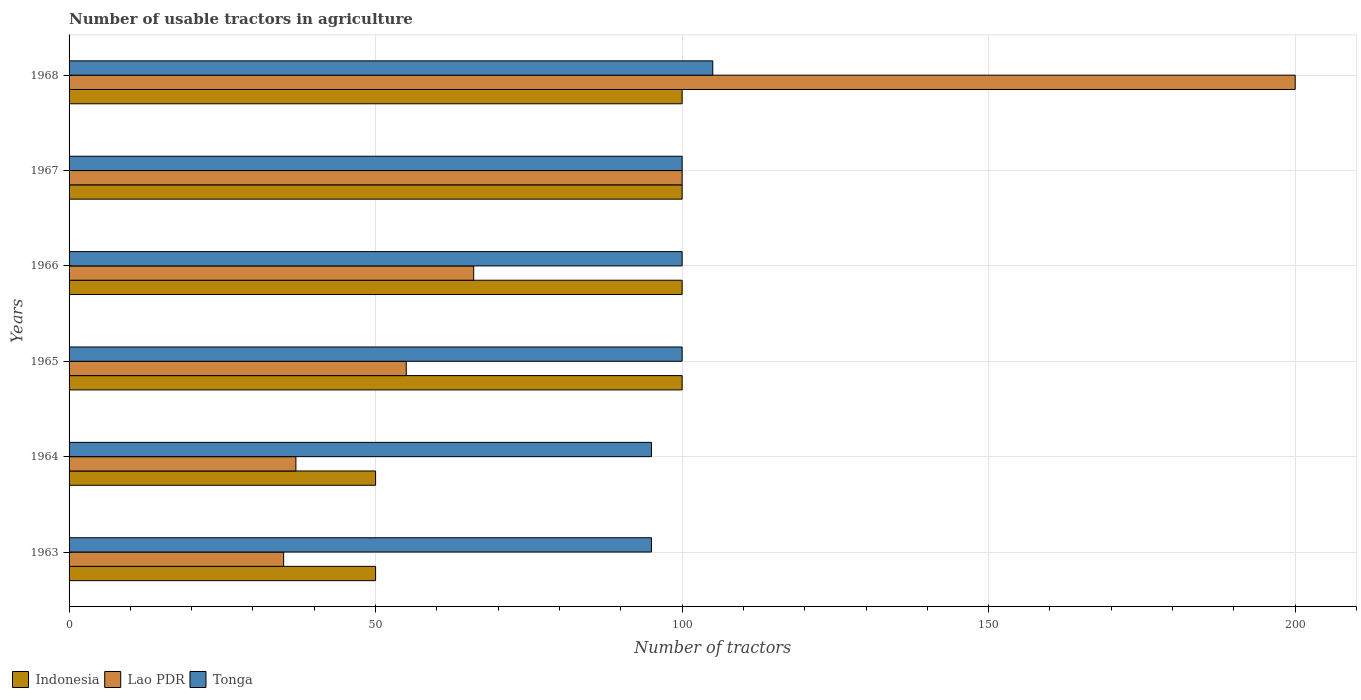Are the number of bars on each tick of the Y-axis equal?
Your answer should be very brief. Yes. How many bars are there on the 5th tick from the top?
Offer a very short reply. 3. What is the label of the 2nd group of bars from the top?
Your response must be concise. 1967. In how many cases, is the number of bars for a given year not equal to the number of legend labels?
Ensure brevity in your answer.  0. What is the number of usable tractors in agriculture in Indonesia in 1968?
Offer a terse response. 100. Across all years, what is the maximum number of usable tractors in agriculture in Tonga?
Offer a terse response. 105. In which year was the number of usable tractors in agriculture in Indonesia maximum?
Keep it short and to the point. 1965. What is the total number of usable tractors in agriculture in Lao PDR in the graph?
Offer a terse response. 493. What is the difference between the number of usable tractors in agriculture in Lao PDR in 1966 and that in 1967?
Offer a terse response. -34. What is the difference between the number of usable tractors in agriculture in Lao PDR in 1966 and the number of usable tractors in agriculture in Indonesia in 1965?
Give a very brief answer. -34. What is the average number of usable tractors in agriculture in Tonga per year?
Your response must be concise. 99.17. Is the number of usable tractors in agriculture in Tonga in 1963 less than that in 1965?
Make the answer very short. Yes. Is the difference between the number of usable tractors in agriculture in Tonga in 1965 and 1968 greater than the difference between the number of usable tractors in agriculture in Lao PDR in 1965 and 1968?
Give a very brief answer. Yes. What is the difference between the highest and the second highest number of usable tractors in agriculture in Indonesia?
Provide a short and direct response. 0. What is the difference between the highest and the lowest number of usable tractors in agriculture in Lao PDR?
Keep it short and to the point. 165. What does the 2nd bar from the top in 1963 represents?
Your response must be concise. Lao PDR. Is it the case that in every year, the sum of the number of usable tractors in agriculture in Tonga and number of usable tractors in agriculture in Indonesia is greater than the number of usable tractors in agriculture in Lao PDR?
Your response must be concise. Yes. How many bars are there?
Ensure brevity in your answer.  18. Are all the bars in the graph horizontal?
Provide a succinct answer. Yes. Does the graph contain any zero values?
Offer a very short reply. No. Does the graph contain grids?
Make the answer very short. Yes. What is the title of the graph?
Your response must be concise. Number of usable tractors in agriculture. What is the label or title of the X-axis?
Provide a short and direct response. Number of tractors. What is the label or title of the Y-axis?
Provide a short and direct response. Years. What is the Number of tractors in Tonga in 1963?
Your answer should be compact. 95. What is the Number of tractors of Lao PDR in 1966?
Offer a very short reply. 66. What is the Number of tractors in Indonesia in 1967?
Offer a very short reply. 100. What is the Number of tractors in Lao PDR in 1967?
Give a very brief answer. 100. What is the Number of tractors of Indonesia in 1968?
Your response must be concise. 100. What is the Number of tractors of Lao PDR in 1968?
Keep it short and to the point. 200. What is the Number of tractors in Tonga in 1968?
Provide a short and direct response. 105. Across all years, what is the maximum Number of tractors of Lao PDR?
Offer a terse response. 200. Across all years, what is the maximum Number of tractors of Tonga?
Keep it short and to the point. 105. Across all years, what is the minimum Number of tractors of Indonesia?
Offer a terse response. 50. Across all years, what is the minimum Number of tractors in Lao PDR?
Give a very brief answer. 35. What is the total Number of tractors in Indonesia in the graph?
Give a very brief answer. 500. What is the total Number of tractors in Lao PDR in the graph?
Ensure brevity in your answer.  493. What is the total Number of tractors of Tonga in the graph?
Your response must be concise. 595. What is the difference between the Number of tractors of Indonesia in 1963 and that in 1964?
Your answer should be very brief. 0. What is the difference between the Number of tractors of Lao PDR in 1963 and that in 1966?
Ensure brevity in your answer.  -31. What is the difference between the Number of tractors of Tonga in 1963 and that in 1966?
Ensure brevity in your answer.  -5. What is the difference between the Number of tractors of Lao PDR in 1963 and that in 1967?
Provide a short and direct response. -65. What is the difference between the Number of tractors in Tonga in 1963 and that in 1967?
Your response must be concise. -5. What is the difference between the Number of tractors of Indonesia in 1963 and that in 1968?
Keep it short and to the point. -50. What is the difference between the Number of tractors of Lao PDR in 1963 and that in 1968?
Ensure brevity in your answer.  -165. What is the difference between the Number of tractors of Tonga in 1963 and that in 1968?
Offer a very short reply. -10. What is the difference between the Number of tractors of Tonga in 1964 and that in 1965?
Your response must be concise. -5. What is the difference between the Number of tractors of Tonga in 1964 and that in 1966?
Your answer should be very brief. -5. What is the difference between the Number of tractors of Indonesia in 1964 and that in 1967?
Your answer should be compact. -50. What is the difference between the Number of tractors of Lao PDR in 1964 and that in 1967?
Offer a terse response. -63. What is the difference between the Number of tractors in Indonesia in 1964 and that in 1968?
Provide a short and direct response. -50. What is the difference between the Number of tractors of Lao PDR in 1964 and that in 1968?
Offer a terse response. -163. What is the difference between the Number of tractors in Tonga in 1964 and that in 1968?
Your answer should be compact. -10. What is the difference between the Number of tractors in Indonesia in 1965 and that in 1966?
Your answer should be compact. 0. What is the difference between the Number of tractors in Lao PDR in 1965 and that in 1967?
Provide a short and direct response. -45. What is the difference between the Number of tractors in Tonga in 1965 and that in 1967?
Provide a succinct answer. 0. What is the difference between the Number of tractors of Indonesia in 1965 and that in 1968?
Give a very brief answer. 0. What is the difference between the Number of tractors of Lao PDR in 1965 and that in 1968?
Your response must be concise. -145. What is the difference between the Number of tractors in Indonesia in 1966 and that in 1967?
Provide a succinct answer. 0. What is the difference between the Number of tractors of Lao PDR in 1966 and that in 1967?
Offer a terse response. -34. What is the difference between the Number of tractors in Lao PDR in 1966 and that in 1968?
Your answer should be very brief. -134. What is the difference between the Number of tractors of Tonga in 1966 and that in 1968?
Ensure brevity in your answer.  -5. What is the difference between the Number of tractors of Indonesia in 1967 and that in 1968?
Ensure brevity in your answer.  0. What is the difference between the Number of tractors in Lao PDR in 1967 and that in 1968?
Your response must be concise. -100. What is the difference between the Number of tractors in Tonga in 1967 and that in 1968?
Offer a very short reply. -5. What is the difference between the Number of tractors in Indonesia in 1963 and the Number of tractors in Tonga in 1964?
Your answer should be compact. -45. What is the difference between the Number of tractors in Lao PDR in 1963 and the Number of tractors in Tonga in 1964?
Give a very brief answer. -60. What is the difference between the Number of tractors in Lao PDR in 1963 and the Number of tractors in Tonga in 1965?
Your answer should be compact. -65. What is the difference between the Number of tractors of Lao PDR in 1963 and the Number of tractors of Tonga in 1966?
Offer a terse response. -65. What is the difference between the Number of tractors of Indonesia in 1963 and the Number of tractors of Lao PDR in 1967?
Provide a succinct answer. -50. What is the difference between the Number of tractors of Indonesia in 1963 and the Number of tractors of Tonga in 1967?
Ensure brevity in your answer.  -50. What is the difference between the Number of tractors in Lao PDR in 1963 and the Number of tractors in Tonga in 1967?
Your answer should be very brief. -65. What is the difference between the Number of tractors of Indonesia in 1963 and the Number of tractors of Lao PDR in 1968?
Your answer should be very brief. -150. What is the difference between the Number of tractors in Indonesia in 1963 and the Number of tractors in Tonga in 1968?
Offer a terse response. -55. What is the difference between the Number of tractors in Lao PDR in 1963 and the Number of tractors in Tonga in 1968?
Keep it short and to the point. -70. What is the difference between the Number of tractors of Lao PDR in 1964 and the Number of tractors of Tonga in 1965?
Offer a very short reply. -63. What is the difference between the Number of tractors of Indonesia in 1964 and the Number of tractors of Lao PDR in 1966?
Offer a terse response. -16. What is the difference between the Number of tractors of Indonesia in 1964 and the Number of tractors of Tonga in 1966?
Keep it short and to the point. -50. What is the difference between the Number of tractors of Lao PDR in 1964 and the Number of tractors of Tonga in 1966?
Provide a short and direct response. -63. What is the difference between the Number of tractors of Lao PDR in 1964 and the Number of tractors of Tonga in 1967?
Your answer should be compact. -63. What is the difference between the Number of tractors in Indonesia in 1964 and the Number of tractors in Lao PDR in 1968?
Your response must be concise. -150. What is the difference between the Number of tractors of Indonesia in 1964 and the Number of tractors of Tonga in 1968?
Your answer should be very brief. -55. What is the difference between the Number of tractors of Lao PDR in 1964 and the Number of tractors of Tonga in 1968?
Your answer should be compact. -68. What is the difference between the Number of tractors of Indonesia in 1965 and the Number of tractors of Lao PDR in 1966?
Provide a short and direct response. 34. What is the difference between the Number of tractors in Lao PDR in 1965 and the Number of tractors in Tonga in 1966?
Make the answer very short. -45. What is the difference between the Number of tractors in Indonesia in 1965 and the Number of tractors in Lao PDR in 1967?
Your response must be concise. 0. What is the difference between the Number of tractors in Indonesia in 1965 and the Number of tractors in Tonga in 1967?
Your response must be concise. 0. What is the difference between the Number of tractors in Lao PDR in 1965 and the Number of tractors in Tonga in 1967?
Keep it short and to the point. -45. What is the difference between the Number of tractors of Indonesia in 1965 and the Number of tractors of Lao PDR in 1968?
Offer a very short reply. -100. What is the difference between the Number of tractors of Indonesia in 1965 and the Number of tractors of Tonga in 1968?
Give a very brief answer. -5. What is the difference between the Number of tractors in Indonesia in 1966 and the Number of tractors in Lao PDR in 1967?
Offer a terse response. 0. What is the difference between the Number of tractors in Lao PDR in 1966 and the Number of tractors in Tonga in 1967?
Your answer should be very brief. -34. What is the difference between the Number of tractors in Indonesia in 1966 and the Number of tractors in Lao PDR in 1968?
Keep it short and to the point. -100. What is the difference between the Number of tractors in Lao PDR in 1966 and the Number of tractors in Tonga in 1968?
Give a very brief answer. -39. What is the difference between the Number of tractors in Indonesia in 1967 and the Number of tractors in Lao PDR in 1968?
Provide a short and direct response. -100. What is the difference between the Number of tractors of Lao PDR in 1967 and the Number of tractors of Tonga in 1968?
Give a very brief answer. -5. What is the average Number of tractors in Indonesia per year?
Your answer should be very brief. 83.33. What is the average Number of tractors in Lao PDR per year?
Your answer should be very brief. 82.17. What is the average Number of tractors of Tonga per year?
Provide a succinct answer. 99.17. In the year 1963, what is the difference between the Number of tractors in Indonesia and Number of tractors in Tonga?
Provide a short and direct response. -45. In the year 1963, what is the difference between the Number of tractors of Lao PDR and Number of tractors of Tonga?
Offer a very short reply. -60. In the year 1964, what is the difference between the Number of tractors in Indonesia and Number of tractors in Tonga?
Your answer should be compact. -45. In the year 1964, what is the difference between the Number of tractors in Lao PDR and Number of tractors in Tonga?
Your response must be concise. -58. In the year 1965, what is the difference between the Number of tractors in Indonesia and Number of tractors in Lao PDR?
Your response must be concise. 45. In the year 1965, what is the difference between the Number of tractors of Indonesia and Number of tractors of Tonga?
Your answer should be compact. 0. In the year 1965, what is the difference between the Number of tractors of Lao PDR and Number of tractors of Tonga?
Keep it short and to the point. -45. In the year 1966, what is the difference between the Number of tractors in Indonesia and Number of tractors in Tonga?
Keep it short and to the point. 0. In the year 1966, what is the difference between the Number of tractors of Lao PDR and Number of tractors of Tonga?
Your response must be concise. -34. In the year 1967, what is the difference between the Number of tractors of Lao PDR and Number of tractors of Tonga?
Provide a succinct answer. 0. In the year 1968, what is the difference between the Number of tractors in Indonesia and Number of tractors in Lao PDR?
Ensure brevity in your answer.  -100. In the year 1968, what is the difference between the Number of tractors of Indonesia and Number of tractors of Tonga?
Your answer should be very brief. -5. What is the ratio of the Number of tractors of Indonesia in 1963 to that in 1964?
Your answer should be very brief. 1. What is the ratio of the Number of tractors in Lao PDR in 1963 to that in 1964?
Keep it short and to the point. 0.95. What is the ratio of the Number of tractors of Lao PDR in 1963 to that in 1965?
Offer a terse response. 0.64. What is the ratio of the Number of tractors of Tonga in 1963 to that in 1965?
Offer a very short reply. 0.95. What is the ratio of the Number of tractors of Lao PDR in 1963 to that in 1966?
Offer a very short reply. 0.53. What is the ratio of the Number of tractors of Indonesia in 1963 to that in 1967?
Your answer should be compact. 0.5. What is the ratio of the Number of tractors of Lao PDR in 1963 to that in 1967?
Offer a terse response. 0.35. What is the ratio of the Number of tractors in Tonga in 1963 to that in 1967?
Ensure brevity in your answer.  0.95. What is the ratio of the Number of tractors of Indonesia in 1963 to that in 1968?
Your answer should be very brief. 0.5. What is the ratio of the Number of tractors in Lao PDR in 1963 to that in 1968?
Your response must be concise. 0.17. What is the ratio of the Number of tractors in Tonga in 1963 to that in 1968?
Your answer should be very brief. 0.9. What is the ratio of the Number of tractors in Lao PDR in 1964 to that in 1965?
Offer a terse response. 0.67. What is the ratio of the Number of tractors of Lao PDR in 1964 to that in 1966?
Your answer should be very brief. 0.56. What is the ratio of the Number of tractors in Tonga in 1964 to that in 1966?
Make the answer very short. 0.95. What is the ratio of the Number of tractors in Lao PDR in 1964 to that in 1967?
Ensure brevity in your answer.  0.37. What is the ratio of the Number of tractors in Indonesia in 1964 to that in 1968?
Provide a succinct answer. 0.5. What is the ratio of the Number of tractors of Lao PDR in 1964 to that in 1968?
Give a very brief answer. 0.18. What is the ratio of the Number of tractors of Tonga in 1964 to that in 1968?
Provide a short and direct response. 0.9. What is the ratio of the Number of tractors in Indonesia in 1965 to that in 1966?
Keep it short and to the point. 1. What is the ratio of the Number of tractors of Indonesia in 1965 to that in 1967?
Your answer should be very brief. 1. What is the ratio of the Number of tractors of Lao PDR in 1965 to that in 1967?
Ensure brevity in your answer.  0.55. What is the ratio of the Number of tractors of Indonesia in 1965 to that in 1968?
Offer a terse response. 1. What is the ratio of the Number of tractors of Lao PDR in 1965 to that in 1968?
Your response must be concise. 0.28. What is the ratio of the Number of tractors of Tonga in 1965 to that in 1968?
Your response must be concise. 0.95. What is the ratio of the Number of tractors of Lao PDR in 1966 to that in 1967?
Make the answer very short. 0.66. What is the ratio of the Number of tractors in Tonga in 1966 to that in 1967?
Provide a succinct answer. 1. What is the ratio of the Number of tractors of Indonesia in 1966 to that in 1968?
Offer a terse response. 1. What is the ratio of the Number of tractors of Lao PDR in 1966 to that in 1968?
Offer a very short reply. 0.33. What is the ratio of the Number of tractors of Tonga in 1966 to that in 1968?
Keep it short and to the point. 0.95. What is the ratio of the Number of tractors in Lao PDR in 1967 to that in 1968?
Your answer should be very brief. 0.5. What is the difference between the highest and the second highest Number of tractors of Indonesia?
Keep it short and to the point. 0. What is the difference between the highest and the second highest Number of tractors of Tonga?
Make the answer very short. 5. What is the difference between the highest and the lowest Number of tractors of Indonesia?
Keep it short and to the point. 50. What is the difference between the highest and the lowest Number of tractors in Lao PDR?
Provide a short and direct response. 165. 